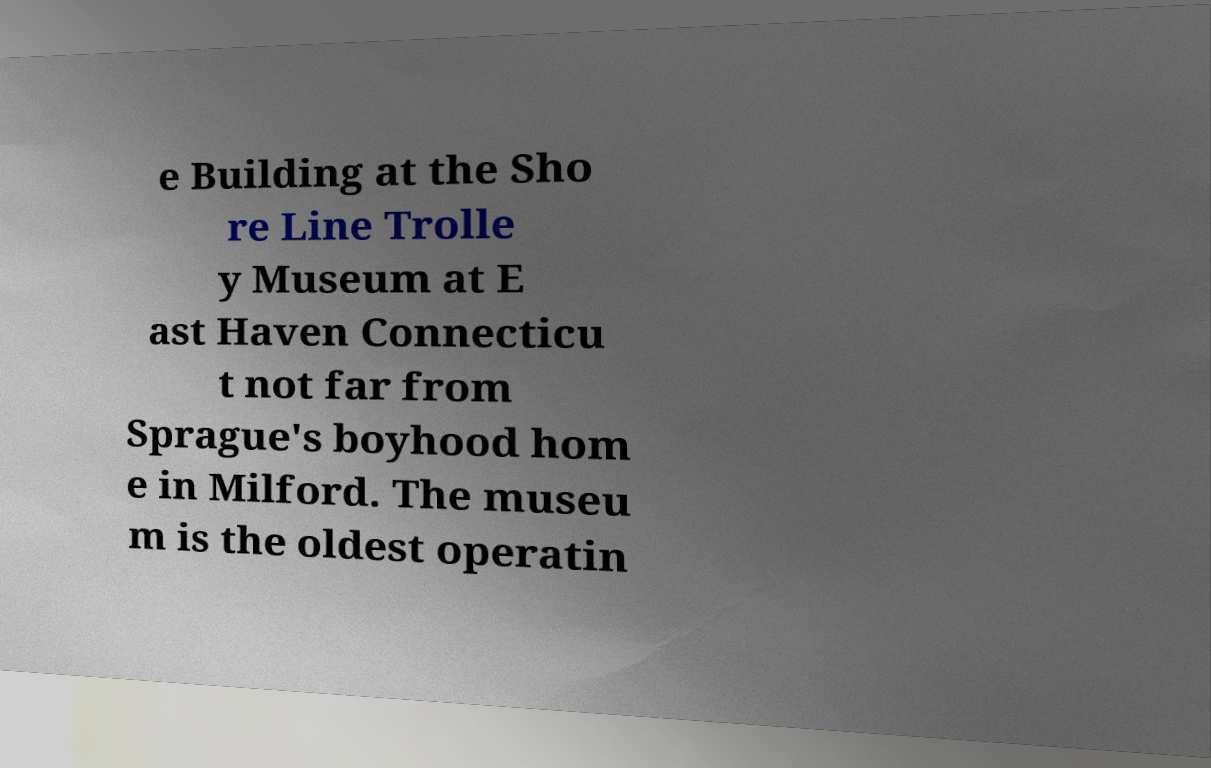What messages or text are displayed in this image? I need them in a readable, typed format. e Building at the Sho re Line Trolle y Museum at E ast Haven Connecticu t not far from Sprague's boyhood hom e in Milford. The museu m is the oldest operatin 